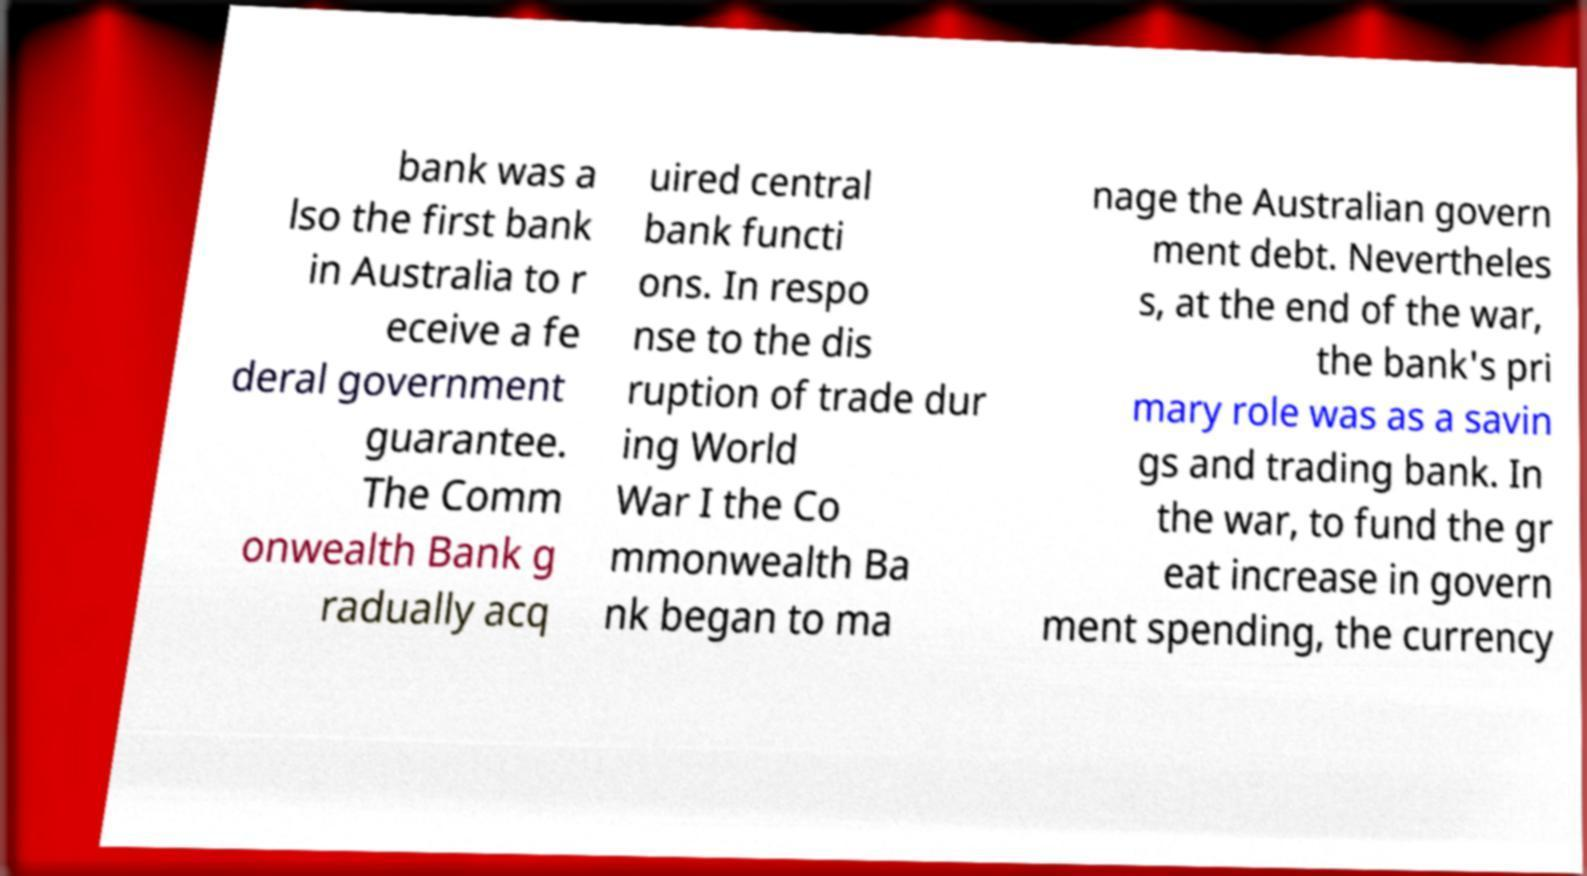For documentation purposes, I need the text within this image transcribed. Could you provide that? bank was a lso the first bank in Australia to r eceive a fe deral government guarantee. The Comm onwealth Bank g radually acq uired central bank functi ons. In respo nse to the dis ruption of trade dur ing World War I the Co mmonwealth Ba nk began to ma nage the Australian govern ment debt. Nevertheles s, at the end of the war, the bank's pri mary role was as a savin gs and trading bank. In the war, to fund the gr eat increase in govern ment spending, the currency 